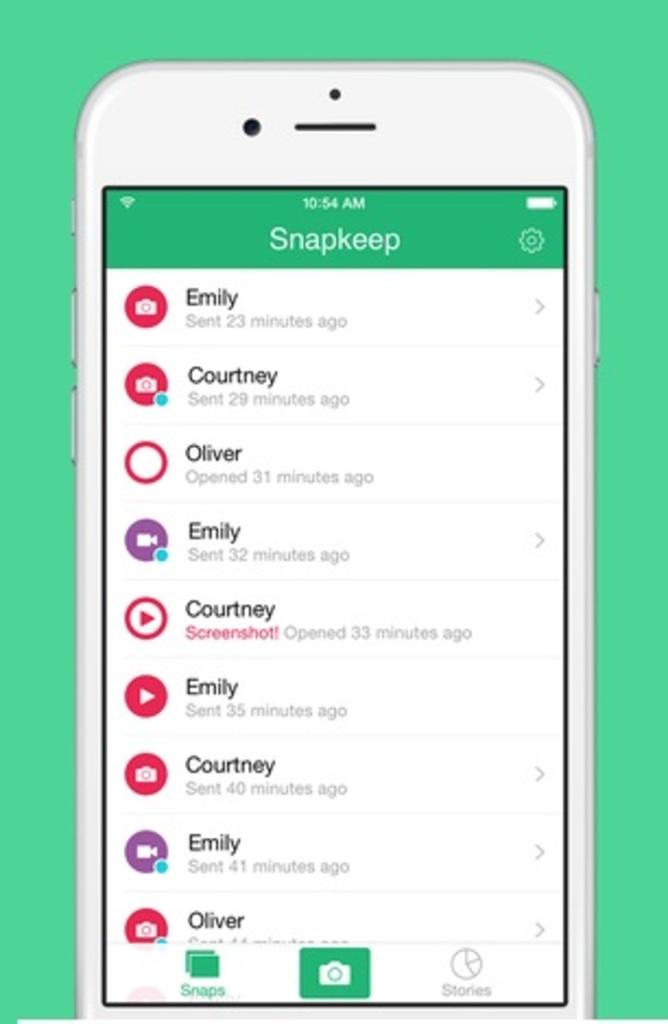Provide a one-sentence caption for the provided image. Emily, Courtney and Oliver are in a Snapkeep group. 